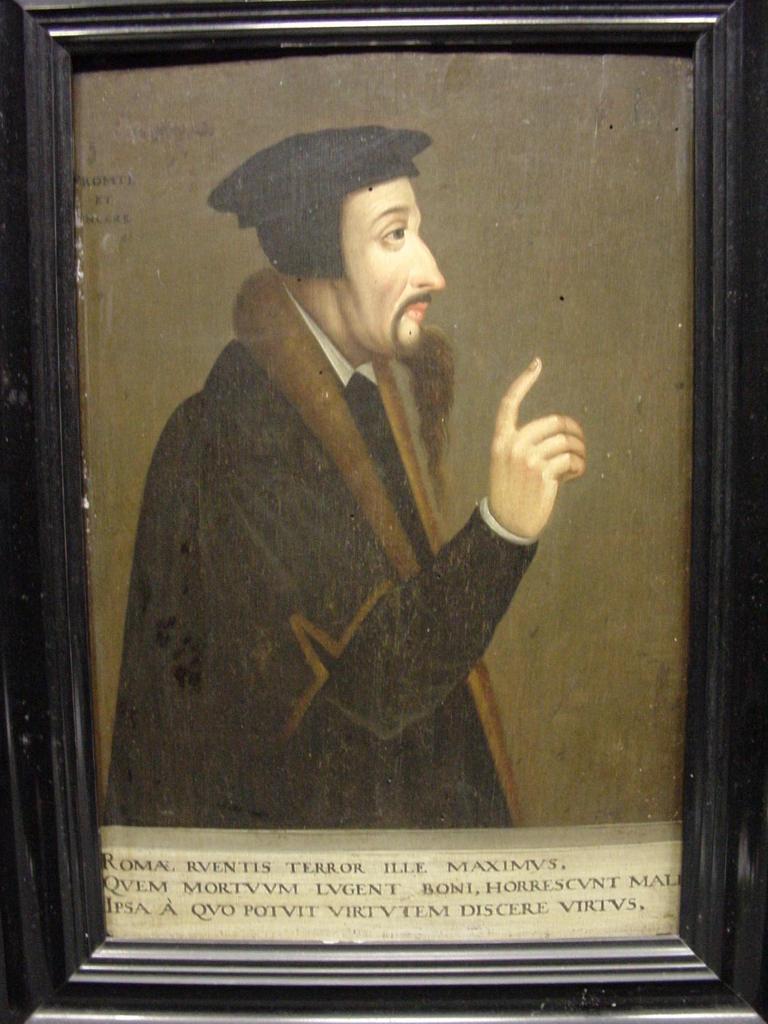Could you give a brief overview of what you see in this image? In this image I can see the black colored photo frame and a photograph of a person wearing brown and black colored dress. I can see something is written at the bottom of the image. 